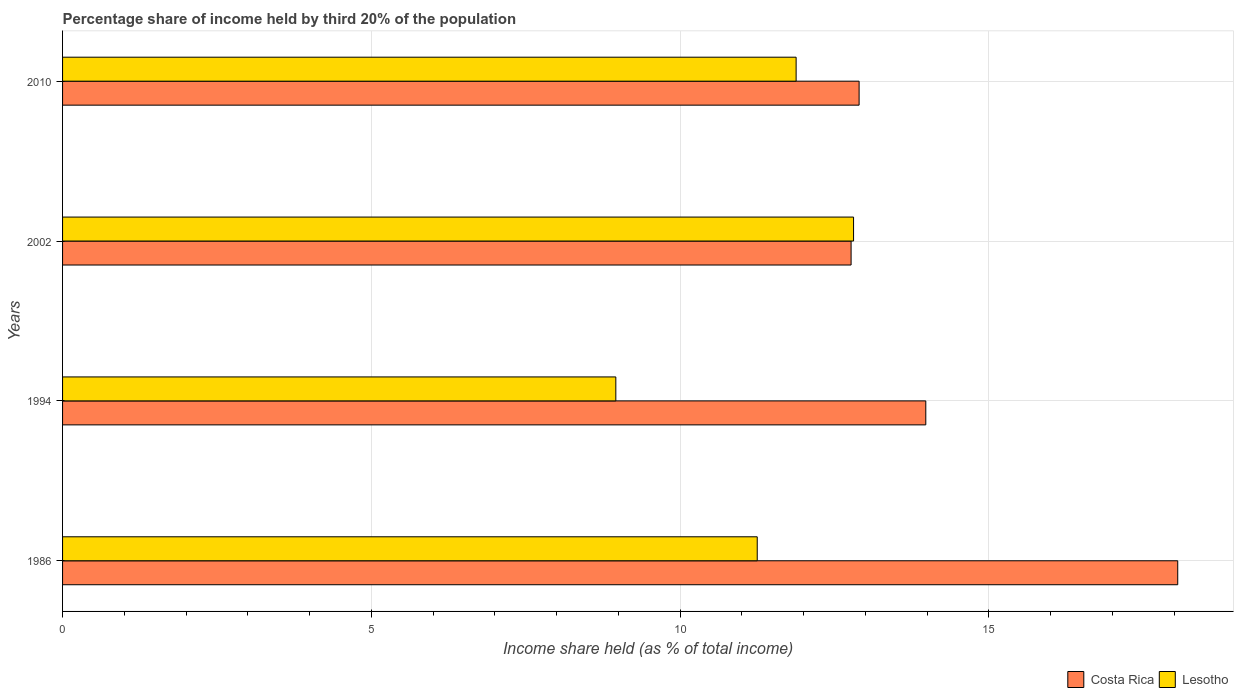How many different coloured bars are there?
Your response must be concise. 2. How many groups of bars are there?
Offer a very short reply. 4. Are the number of bars per tick equal to the number of legend labels?
Provide a short and direct response. Yes. What is the label of the 3rd group of bars from the top?
Keep it short and to the point. 1994. In how many cases, is the number of bars for a given year not equal to the number of legend labels?
Keep it short and to the point. 0. What is the share of income held by third 20% of the population in Lesotho in 1994?
Make the answer very short. 8.96. Across all years, what is the maximum share of income held by third 20% of the population in Costa Rica?
Offer a very short reply. 18.06. Across all years, what is the minimum share of income held by third 20% of the population in Costa Rica?
Keep it short and to the point. 12.77. What is the total share of income held by third 20% of the population in Lesotho in the graph?
Your answer should be compact. 44.9. What is the difference between the share of income held by third 20% of the population in Lesotho in 2010 and the share of income held by third 20% of the population in Costa Rica in 1986?
Offer a terse response. -6.18. What is the average share of income held by third 20% of the population in Costa Rica per year?
Offer a very short reply. 14.43. In the year 2010, what is the difference between the share of income held by third 20% of the population in Costa Rica and share of income held by third 20% of the population in Lesotho?
Offer a terse response. 1.02. In how many years, is the share of income held by third 20% of the population in Costa Rica greater than 14 %?
Provide a short and direct response. 1. What is the ratio of the share of income held by third 20% of the population in Lesotho in 1994 to that in 2010?
Ensure brevity in your answer.  0.75. Is the share of income held by third 20% of the population in Lesotho in 1986 less than that in 1994?
Provide a succinct answer. No. Is the difference between the share of income held by third 20% of the population in Costa Rica in 1994 and 2010 greater than the difference between the share of income held by third 20% of the population in Lesotho in 1994 and 2010?
Give a very brief answer. Yes. What is the difference between the highest and the second highest share of income held by third 20% of the population in Costa Rica?
Offer a terse response. 4.08. What is the difference between the highest and the lowest share of income held by third 20% of the population in Costa Rica?
Your response must be concise. 5.29. Is the sum of the share of income held by third 20% of the population in Costa Rica in 2002 and 2010 greater than the maximum share of income held by third 20% of the population in Lesotho across all years?
Make the answer very short. Yes. What does the 1st bar from the top in 1994 represents?
Offer a terse response. Lesotho. How many bars are there?
Offer a very short reply. 8. Are all the bars in the graph horizontal?
Keep it short and to the point. Yes. What is the difference between two consecutive major ticks on the X-axis?
Your answer should be very brief. 5. Are the values on the major ticks of X-axis written in scientific E-notation?
Provide a short and direct response. No. Does the graph contain grids?
Keep it short and to the point. Yes. Where does the legend appear in the graph?
Provide a succinct answer. Bottom right. How many legend labels are there?
Provide a short and direct response. 2. What is the title of the graph?
Offer a very short reply. Percentage share of income held by third 20% of the population. Does "Barbados" appear as one of the legend labels in the graph?
Provide a succinct answer. No. What is the label or title of the X-axis?
Offer a terse response. Income share held (as % of total income). What is the Income share held (as % of total income) in Costa Rica in 1986?
Your answer should be very brief. 18.06. What is the Income share held (as % of total income) of Lesotho in 1986?
Offer a terse response. 11.25. What is the Income share held (as % of total income) in Costa Rica in 1994?
Make the answer very short. 13.98. What is the Income share held (as % of total income) of Lesotho in 1994?
Your answer should be very brief. 8.96. What is the Income share held (as % of total income) of Costa Rica in 2002?
Keep it short and to the point. 12.77. What is the Income share held (as % of total income) of Lesotho in 2002?
Your response must be concise. 12.81. What is the Income share held (as % of total income) in Costa Rica in 2010?
Provide a succinct answer. 12.9. What is the Income share held (as % of total income) of Lesotho in 2010?
Give a very brief answer. 11.88. Across all years, what is the maximum Income share held (as % of total income) in Costa Rica?
Provide a succinct answer. 18.06. Across all years, what is the maximum Income share held (as % of total income) of Lesotho?
Make the answer very short. 12.81. Across all years, what is the minimum Income share held (as % of total income) of Costa Rica?
Provide a succinct answer. 12.77. Across all years, what is the minimum Income share held (as % of total income) of Lesotho?
Provide a succinct answer. 8.96. What is the total Income share held (as % of total income) of Costa Rica in the graph?
Offer a terse response. 57.71. What is the total Income share held (as % of total income) of Lesotho in the graph?
Make the answer very short. 44.9. What is the difference between the Income share held (as % of total income) of Costa Rica in 1986 and that in 1994?
Your answer should be very brief. 4.08. What is the difference between the Income share held (as % of total income) of Lesotho in 1986 and that in 1994?
Offer a terse response. 2.29. What is the difference between the Income share held (as % of total income) in Costa Rica in 1986 and that in 2002?
Offer a very short reply. 5.29. What is the difference between the Income share held (as % of total income) of Lesotho in 1986 and that in 2002?
Provide a short and direct response. -1.56. What is the difference between the Income share held (as % of total income) in Costa Rica in 1986 and that in 2010?
Give a very brief answer. 5.16. What is the difference between the Income share held (as % of total income) of Lesotho in 1986 and that in 2010?
Make the answer very short. -0.63. What is the difference between the Income share held (as % of total income) in Costa Rica in 1994 and that in 2002?
Keep it short and to the point. 1.21. What is the difference between the Income share held (as % of total income) of Lesotho in 1994 and that in 2002?
Make the answer very short. -3.85. What is the difference between the Income share held (as % of total income) of Costa Rica in 1994 and that in 2010?
Your answer should be compact. 1.08. What is the difference between the Income share held (as % of total income) of Lesotho in 1994 and that in 2010?
Ensure brevity in your answer.  -2.92. What is the difference between the Income share held (as % of total income) of Costa Rica in 2002 and that in 2010?
Provide a short and direct response. -0.13. What is the difference between the Income share held (as % of total income) of Lesotho in 2002 and that in 2010?
Provide a short and direct response. 0.93. What is the difference between the Income share held (as % of total income) of Costa Rica in 1986 and the Income share held (as % of total income) of Lesotho in 1994?
Your answer should be very brief. 9.1. What is the difference between the Income share held (as % of total income) of Costa Rica in 1986 and the Income share held (as % of total income) of Lesotho in 2002?
Keep it short and to the point. 5.25. What is the difference between the Income share held (as % of total income) in Costa Rica in 1986 and the Income share held (as % of total income) in Lesotho in 2010?
Your answer should be compact. 6.18. What is the difference between the Income share held (as % of total income) in Costa Rica in 1994 and the Income share held (as % of total income) in Lesotho in 2002?
Provide a short and direct response. 1.17. What is the difference between the Income share held (as % of total income) in Costa Rica in 1994 and the Income share held (as % of total income) in Lesotho in 2010?
Ensure brevity in your answer.  2.1. What is the difference between the Income share held (as % of total income) in Costa Rica in 2002 and the Income share held (as % of total income) in Lesotho in 2010?
Give a very brief answer. 0.89. What is the average Income share held (as % of total income) of Costa Rica per year?
Your answer should be compact. 14.43. What is the average Income share held (as % of total income) in Lesotho per year?
Your answer should be compact. 11.22. In the year 1986, what is the difference between the Income share held (as % of total income) of Costa Rica and Income share held (as % of total income) of Lesotho?
Provide a succinct answer. 6.81. In the year 1994, what is the difference between the Income share held (as % of total income) of Costa Rica and Income share held (as % of total income) of Lesotho?
Offer a terse response. 5.02. In the year 2002, what is the difference between the Income share held (as % of total income) in Costa Rica and Income share held (as % of total income) in Lesotho?
Offer a terse response. -0.04. In the year 2010, what is the difference between the Income share held (as % of total income) in Costa Rica and Income share held (as % of total income) in Lesotho?
Give a very brief answer. 1.02. What is the ratio of the Income share held (as % of total income) in Costa Rica in 1986 to that in 1994?
Provide a short and direct response. 1.29. What is the ratio of the Income share held (as % of total income) of Lesotho in 1986 to that in 1994?
Your answer should be compact. 1.26. What is the ratio of the Income share held (as % of total income) in Costa Rica in 1986 to that in 2002?
Offer a very short reply. 1.41. What is the ratio of the Income share held (as % of total income) of Lesotho in 1986 to that in 2002?
Offer a terse response. 0.88. What is the ratio of the Income share held (as % of total income) in Lesotho in 1986 to that in 2010?
Your answer should be very brief. 0.95. What is the ratio of the Income share held (as % of total income) of Costa Rica in 1994 to that in 2002?
Make the answer very short. 1.09. What is the ratio of the Income share held (as % of total income) in Lesotho in 1994 to that in 2002?
Your answer should be compact. 0.7. What is the ratio of the Income share held (as % of total income) of Costa Rica in 1994 to that in 2010?
Your response must be concise. 1.08. What is the ratio of the Income share held (as % of total income) of Lesotho in 1994 to that in 2010?
Keep it short and to the point. 0.75. What is the ratio of the Income share held (as % of total income) of Lesotho in 2002 to that in 2010?
Your answer should be compact. 1.08. What is the difference between the highest and the second highest Income share held (as % of total income) in Costa Rica?
Ensure brevity in your answer.  4.08. What is the difference between the highest and the lowest Income share held (as % of total income) of Costa Rica?
Provide a succinct answer. 5.29. What is the difference between the highest and the lowest Income share held (as % of total income) in Lesotho?
Give a very brief answer. 3.85. 